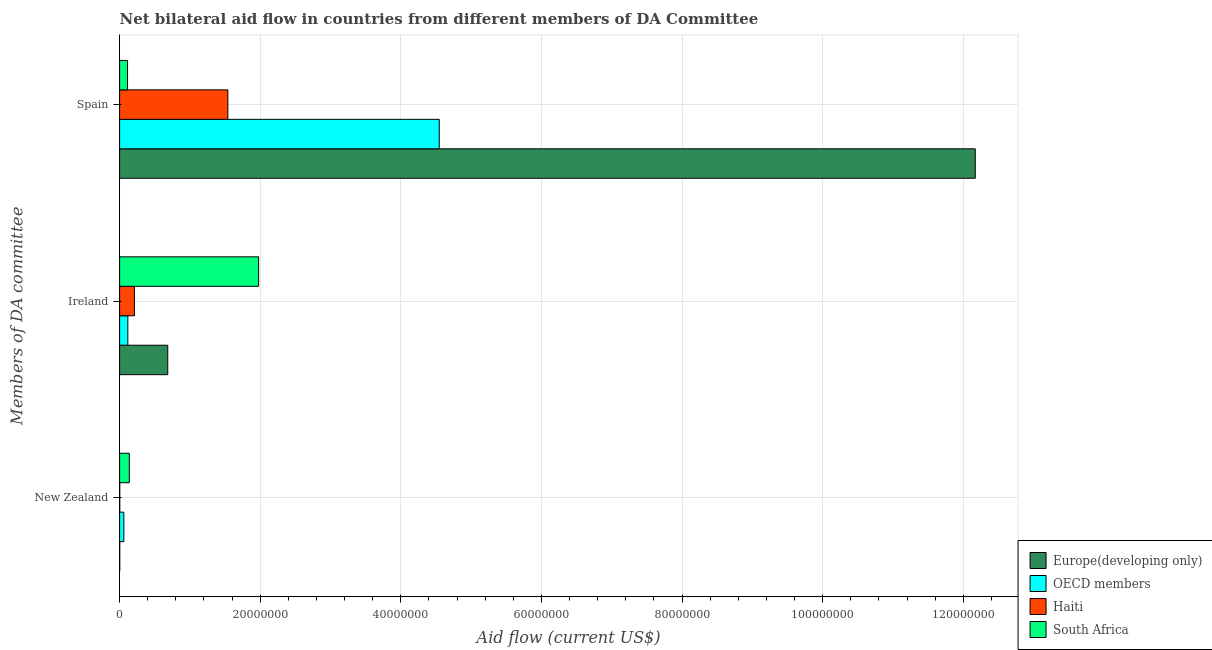How many different coloured bars are there?
Your answer should be compact. 4. How many bars are there on the 3rd tick from the top?
Your answer should be compact. 4. How many bars are there on the 1st tick from the bottom?
Give a very brief answer. 4. What is the label of the 1st group of bars from the top?
Make the answer very short. Spain. What is the amount of aid provided by new zealand in OECD members?
Your response must be concise. 6.00e+05. Across all countries, what is the maximum amount of aid provided by spain?
Offer a very short reply. 1.22e+08. Across all countries, what is the minimum amount of aid provided by new zealand?
Your answer should be compact. 2.00e+04. In which country was the amount of aid provided by new zealand maximum?
Your answer should be very brief. South Africa. What is the total amount of aid provided by ireland in the graph?
Give a very brief answer. 2.99e+07. What is the difference between the amount of aid provided by new zealand in Haiti and that in OECD members?
Your answer should be compact. -5.80e+05. What is the difference between the amount of aid provided by new zealand in Haiti and the amount of aid provided by spain in OECD members?
Offer a very short reply. -4.54e+07. What is the average amount of aid provided by new zealand per country?
Provide a succinct answer. 5.05e+05. What is the difference between the amount of aid provided by spain and amount of aid provided by ireland in South Africa?
Make the answer very short. -1.86e+07. In how many countries, is the amount of aid provided by ireland greater than 32000000 US$?
Your response must be concise. 0. What is the ratio of the amount of aid provided by new zealand in OECD members to that in South Africa?
Provide a succinct answer. 0.43. Is the amount of aid provided by spain in OECD members less than that in South Africa?
Provide a succinct answer. No. What is the difference between the highest and the second highest amount of aid provided by new zealand?
Make the answer very short. 7.80e+05. What is the difference between the highest and the lowest amount of aid provided by spain?
Make the answer very short. 1.21e+08. In how many countries, is the amount of aid provided by new zealand greater than the average amount of aid provided by new zealand taken over all countries?
Your answer should be very brief. 2. Is the sum of the amount of aid provided by spain in OECD members and Europe(developing only) greater than the maximum amount of aid provided by ireland across all countries?
Offer a terse response. Yes. What does the 2nd bar from the top in Spain represents?
Keep it short and to the point. Haiti. What does the 1st bar from the bottom in New Zealand represents?
Your answer should be compact. Europe(developing only). What is the difference between two consecutive major ticks on the X-axis?
Your answer should be very brief. 2.00e+07. Where does the legend appear in the graph?
Offer a very short reply. Bottom right. How are the legend labels stacked?
Your answer should be compact. Vertical. What is the title of the graph?
Give a very brief answer. Net bilateral aid flow in countries from different members of DA Committee. Does "Gambia, The" appear as one of the legend labels in the graph?
Your answer should be very brief. No. What is the label or title of the Y-axis?
Your response must be concise. Members of DA committee. What is the Aid flow (current US$) in Europe(developing only) in New Zealand?
Give a very brief answer. 2.00e+04. What is the Aid flow (current US$) in OECD members in New Zealand?
Your answer should be compact. 6.00e+05. What is the Aid flow (current US$) in South Africa in New Zealand?
Offer a terse response. 1.38e+06. What is the Aid flow (current US$) in Europe(developing only) in Ireland?
Make the answer very short. 6.85e+06. What is the Aid flow (current US$) in OECD members in Ireland?
Offer a terse response. 1.17e+06. What is the Aid flow (current US$) in Haiti in Ireland?
Ensure brevity in your answer.  2.11e+06. What is the Aid flow (current US$) of South Africa in Ireland?
Ensure brevity in your answer.  1.98e+07. What is the Aid flow (current US$) in Europe(developing only) in Spain?
Provide a succinct answer. 1.22e+08. What is the Aid flow (current US$) of OECD members in Spain?
Make the answer very short. 4.55e+07. What is the Aid flow (current US$) in Haiti in Spain?
Provide a succinct answer. 1.54e+07. What is the Aid flow (current US$) of South Africa in Spain?
Offer a terse response. 1.13e+06. Across all Members of DA committee, what is the maximum Aid flow (current US$) of Europe(developing only)?
Provide a succinct answer. 1.22e+08. Across all Members of DA committee, what is the maximum Aid flow (current US$) of OECD members?
Ensure brevity in your answer.  4.55e+07. Across all Members of DA committee, what is the maximum Aid flow (current US$) of Haiti?
Provide a succinct answer. 1.54e+07. Across all Members of DA committee, what is the maximum Aid flow (current US$) in South Africa?
Your response must be concise. 1.98e+07. Across all Members of DA committee, what is the minimum Aid flow (current US$) in OECD members?
Give a very brief answer. 6.00e+05. Across all Members of DA committee, what is the minimum Aid flow (current US$) in South Africa?
Offer a very short reply. 1.13e+06. What is the total Aid flow (current US$) in Europe(developing only) in the graph?
Your answer should be compact. 1.29e+08. What is the total Aid flow (current US$) of OECD members in the graph?
Keep it short and to the point. 4.72e+07. What is the total Aid flow (current US$) in Haiti in the graph?
Your answer should be very brief. 1.75e+07. What is the total Aid flow (current US$) of South Africa in the graph?
Your answer should be very brief. 2.23e+07. What is the difference between the Aid flow (current US$) of Europe(developing only) in New Zealand and that in Ireland?
Your response must be concise. -6.83e+06. What is the difference between the Aid flow (current US$) of OECD members in New Zealand and that in Ireland?
Ensure brevity in your answer.  -5.70e+05. What is the difference between the Aid flow (current US$) of Haiti in New Zealand and that in Ireland?
Your answer should be very brief. -2.09e+06. What is the difference between the Aid flow (current US$) in South Africa in New Zealand and that in Ireland?
Your answer should be compact. -1.84e+07. What is the difference between the Aid flow (current US$) of Europe(developing only) in New Zealand and that in Spain?
Ensure brevity in your answer.  -1.22e+08. What is the difference between the Aid flow (current US$) of OECD members in New Zealand and that in Spain?
Offer a very short reply. -4.49e+07. What is the difference between the Aid flow (current US$) in Haiti in New Zealand and that in Spain?
Provide a succinct answer. -1.54e+07. What is the difference between the Aid flow (current US$) in Europe(developing only) in Ireland and that in Spain?
Offer a terse response. -1.15e+08. What is the difference between the Aid flow (current US$) in OECD members in Ireland and that in Spain?
Give a very brief answer. -4.43e+07. What is the difference between the Aid flow (current US$) in Haiti in Ireland and that in Spain?
Make the answer very short. -1.33e+07. What is the difference between the Aid flow (current US$) in South Africa in Ireland and that in Spain?
Offer a terse response. 1.86e+07. What is the difference between the Aid flow (current US$) in Europe(developing only) in New Zealand and the Aid flow (current US$) in OECD members in Ireland?
Keep it short and to the point. -1.15e+06. What is the difference between the Aid flow (current US$) in Europe(developing only) in New Zealand and the Aid flow (current US$) in Haiti in Ireland?
Provide a short and direct response. -2.09e+06. What is the difference between the Aid flow (current US$) in Europe(developing only) in New Zealand and the Aid flow (current US$) in South Africa in Ireland?
Offer a terse response. -1.98e+07. What is the difference between the Aid flow (current US$) in OECD members in New Zealand and the Aid flow (current US$) in Haiti in Ireland?
Your answer should be compact. -1.51e+06. What is the difference between the Aid flow (current US$) in OECD members in New Zealand and the Aid flow (current US$) in South Africa in Ireland?
Make the answer very short. -1.92e+07. What is the difference between the Aid flow (current US$) of Haiti in New Zealand and the Aid flow (current US$) of South Africa in Ireland?
Make the answer very short. -1.98e+07. What is the difference between the Aid flow (current US$) in Europe(developing only) in New Zealand and the Aid flow (current US$) in OECD members in Spain?
Offer a very short reply. -4.54e+07. What is the difference between the Aid flow (current US$) in Europe(developing only) in New Zealand and the Aid flow (current US$) in Haiti in Spain?
Provide a succinct answer. -1.54e+07. What is the difference between the Aid flow (current US$) of Europe(developing only) in New Zealand and the Aid flow (current US$) of South Africa in Spain?
Ensure brevity in your answer.  -1.11e+06. What is the difference between the Aid flow (current US$) of OECD members in New Zealand and the Aid flow (current US$) of Haiti in Spain?
Make the answer very short. -1.48e+07. What is the difference between the Aid flow (current US$) in OECD members in New Zealand and the Aid flow (current US$) in South Africa in Spain?
Make the answer very short. -5.30e+05. What is the difference between the Aid flow (current US$) in Haiti in New Zealand and the Aid flow (current US$) in South Africa in Spain?
Offer a very short reply. -1.11e+06. What is the difference between the Aid flow (current US$) in Europe(developing only) in Ireland and the Aid flow (current US$) in OECD members in Spain?
Your answer should be compact. -3.86e+07. What is the difference between the Aid flow (current US$) in Europe(developing only) in Ireland and the Aid flow (current US$) in Haiti in Spain?
Offer a very short reply. -8.55e+06. What is the difference between the Aid flow (current US$) of Europe(developing only) in Ireland and the Aid flow (current US$) of South Africa in Spain?
Offer a very short reply. 5.72e+06. What is the difference between the Aid flow (current US$) in OECD members in Ireland and the Aid flow (current US$) in Haiti in Spain?
Provide a succinct answer. -1.42e+07. What is the difference between the Aid flow (current US$) of OECD members in Ireland and the Aid flow (current US$) of South Africa in Spain?
Offer a terse response. 4.00e+04. What is the difference between the Aid flow (current US$) of Haiti in Ireland and the Aid flow (current US$) of South Africa in Spain?
Your answer should be compact. 9.80e+05. What is the average Aid flow (current US$) of Europe(developing only) per Members of DA committee?
Make the answer very short. 4.29e+07. What is the average Aid flow (current US$) of OECD members per Members of DA committee?
Make the answer very short. 1.57e+07. What is the average Aid flow (current US$) in Haiti per Members of DA committee?
Your answer should be very brief. 5.84e+06. What is the average Aid flow (current US$) in South Africa per Members of DA committee?
Keep it short and to the point. 7.43e+06. What is the difference between the Aid flow (current US$) of Europe(developing only) and Aid flow (current US$) of OECD members in New Zealand?
Offer a terse response. -5.80e+05. What is the difference between the Aid flow (current US$) in Europe(developing only) and Aid flow (current US$) in South Africa in New Zealand?
Keep it short and to the point. -1.36e+06. What is the difference between the Aid flow (current US$) in OECD members and Aid flow (current US$) in Haiti in New Zealand?
Your answer should be compact. 5.80e+05. What is the difference between the Aid flow (current US$) of OECD members and Aid flow (current US$) of South Africa in New Zealand?
Your response must be concise. -7.80e+05. What is the difference between the Aid flow (current US$) in Haiti and Aid flow (current US$) in South Africa in New Zealand?
Your answer should be very brief. -1.36e+06. What is the difference between the Aid flow (current US$) in Europe(developing only) and Aid flow (current US$) in OECD members in Ireland?
Offer a terse response. 5.68e+06. What is the difference between the Aid flow (current US$) of Europe(developing only) and Aid flow (current US$) of Haiti in Ireland?
Provide a short and direct response. 4.74e+06. What is the difference between the Aid flow (current US$) in Europe(developing only) and Aid flow (current US$) in South Africa in Ireland?
Provide a short and direct response. -1.29e+07. What is the difference between the Aid flow (current US$) of OECD members and Aid flow (current US$) of Haiti in Ireland?
Offer a terse response. -9.40e+05. What is the difference between the Aid flow (current US$) of OECD members and Aid flow (current US$) of South Africa in Ireland?
Make the answer very short. -1.86e+07. What is the difference between the Aid flow (current US$) of Haiti and Aid flow (current US$) of South Africa in Ireland?
Provide a short and direct response. -1.77e+07. What is the difference between the Aid flow (current US$) of Europe(developing only) and Aid flow (current US$) of OECD members in Spain?
Keep it short and to the point. 7.62e+07. What is the difference between the Aid flow (current US$) of Europe(developing only) and Aid flow (current US$) of Haiti in Spain?
Your answer should be compact. 1.06e+08. What is the difference between the Aid flow (current US$) of Europe(developing only) and Aid flow (current US$) of South Africa in Spain?
Your response must be concise. 1.21e+08. What is the difference between the Aid flow (current US$) in OECD members and Aid flow (current US$) in Haiti in Spain?
Keep it short and to the point. 3.01e+07. What is the difference between the Aid flow (current US$) in OECD members and Aid flow (current US$) in South Africa in Spain?
Keep it short and to the point. 4.43e+07. What is the difference between the Aid flow (current US$) of Haiti and Aid flow (current US$) of South Africa in Spain?
Keep it short and to the point. 1.43e+07. What is the ratio of the Aid flow (current US$) of Europe(developing only) in New Zealand to that in Ireland?
Give a very brief answer. 0. What is the ratio of the Aid flow (current US$) in OECD members in New Zealand to that in Ireland?
Keep it short and to the point. 0.51. What is the ratio of the Aid flow (current US$) in Haiti in New Zealand to that in Ireland?
Offer a very short reply. 0.01. What is the ratio of the Aid flow (current US$) of South Africa in New Zealand to that in Ireland?
Your answer should be compact. 0.07. What is the ratio of the Aid flow (current US$) in Europe(developing only) in New Zealand to that in Spain?
Provide a short and direct response. 0. What is the ratio of the Aid flow (current US$) of OECD members in New Zealand to that in Spain?
Ensure brevity in your answer.  0.01. What is the ratio of the Aid flow (current US$) in Haiti in New Zealand to that in Spain?
Ensure brevity in your answer.  0. What is the ratio of the Aid flow (current US$) in South Africa in New Zealand to that in Spain?
Offer a terse response. 1.22. What is the ratio of the Aid flow (current US$) of Europe(developing only) in Ireland to that in Spain?
Offer a very short reply. 0.06. What is the ratio of the Aid flow (current US$) of OECD members in Ireland to that in Spain?
Provide a short and direct response. 0.03. What is the ratio of the Aid flow (current US$) of Haiti in Ireland to that in Spain?
Provide a short and direct response. 0.14. What is the ratio of the Aid flow (current US$) in South Africa in Ireland to that in Spain?
Offer a terse response. 17.5. What is the difference between the highest and the second highest Aid flow (current US$) of Europe(developing only)?
Give a very brief answer. 1.15e+08. What is the difference between the highest and the second highest Aid flow (current US$) of OECD members?
Your answer should be compact. 4.43e+07. What is the difference between the highest and the second highest Aid flow (current US$) in Haiti?
Keep it short and to the point. 1.33e+07. What is the difference between the highest and the second highest Aid flow (current US$) of South Africa?
Your answer should be very brief. 1.84e+07. What is the difference between the highest and the lowest Aid flow (current US$) in Europe(developing only)?
Provide a short and direct response. 1.22e+08. What is the difference between the highest and the lowest Aid flow (current US$) in OECD members?
Provide a short and direct response. 4.49e+07. What is the difference between the highest and the lowest Aid flow (current US$) of Haiti?
Ensure brevity in your answer.  1.54e+07. What is the difference between the highest and the lowest Aid flow (current US$) in South Africa?
Provide a succinct answer. 1.86e+07. 